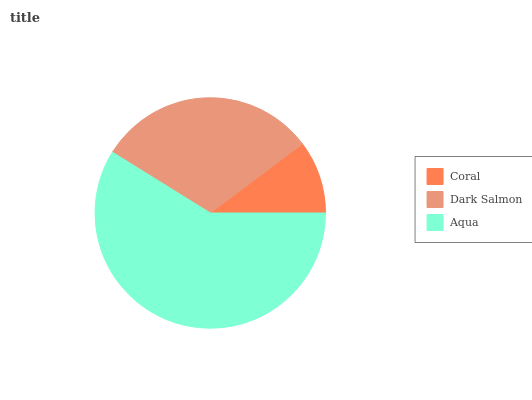Is Coral the minimum?
Answer yes or no. Yes. Is Aqua the maximum?
Answer yes or no. Yes. Is Dark Salmon the minimum?
Answer yes or no. No. Is Dark Salmon the maximum?
Answer yes or no. No. Is Dark Salmon greater than Coral?
Answer yes or no. Yes. Is Coral less than Dark Salmon?
Answer yes or no. Yes. Is Coral greater than Dark Salmon?
Answer yes or no. No. Is Dark Salmon less than Coral?
Answer yes or no. No. Is Dark Salmon the high median?
Answer yes or no. Yes. Is Dark Salmon the low median?
Answer yes or no. Yes. Is Coral the high median?
Answer yes or no. No. Is Aqua the low median?
Answer yes or no. No. 